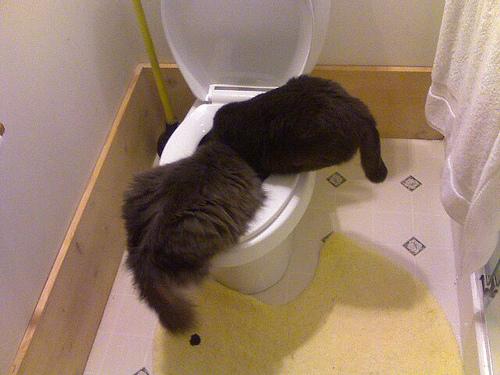How many animals are there?
Answer briefly. 2. What kind of animal is drinking from the toilet?
Be succinct. Cat. Where are the cats?
Be succinct. In toilet. 